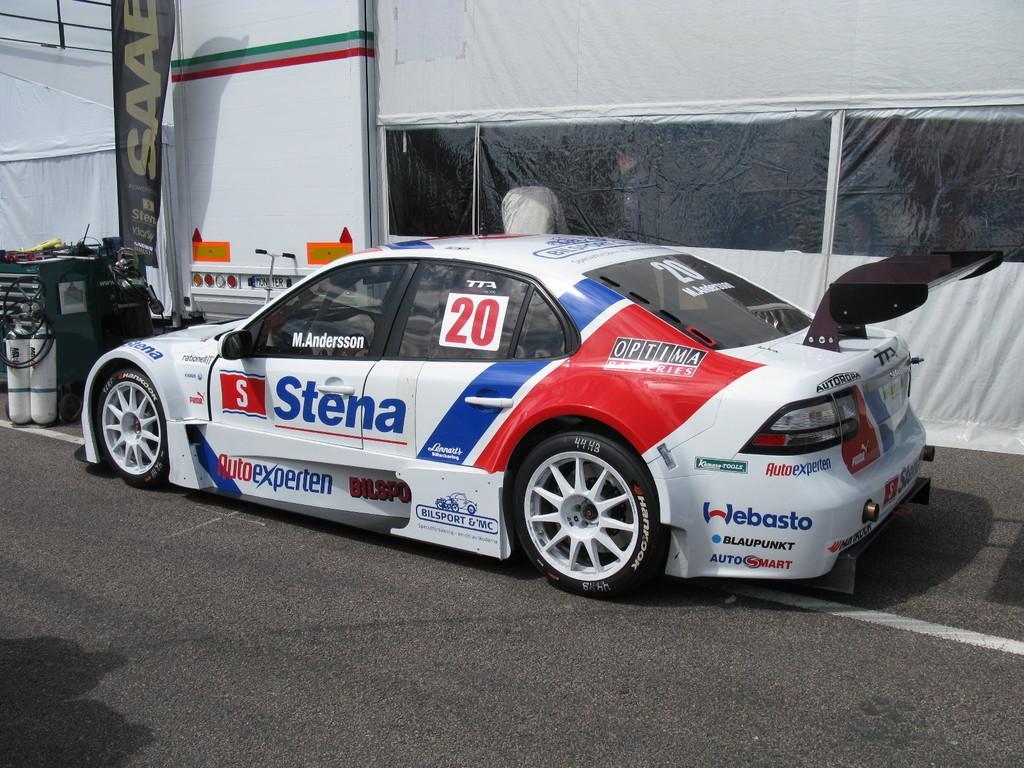Could you give a brief overview of what you see in this image? In this image, we can see a car on the road. In the background, we can see banner, rods, wires, cylinders and some objects. We can see transparent sheets. Through the sheets we can see people. 